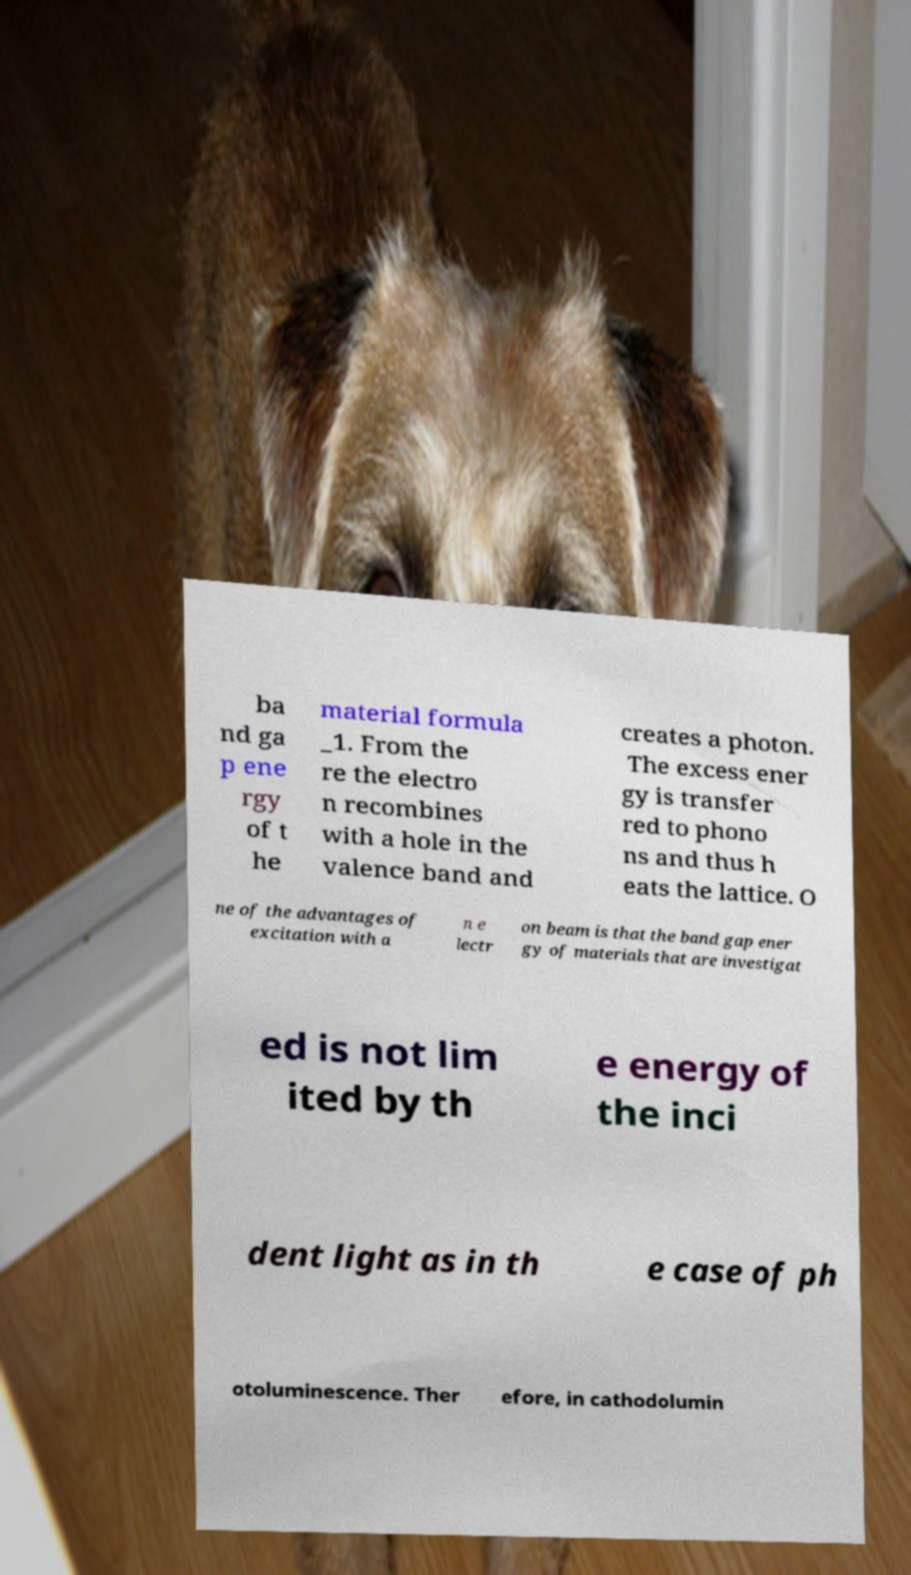Could you extract and type out the text from this image? ba nd ga p ene rgy of t he material formula _1. From the re the electro n recombines with a hole in the valence band and creates a photon. The excess ener gy is transfer red to phono ns and thus h eats the lattice. O ne of the advantages of excitation with a n e lectr on beam is that the band gap ener gy of materials that are investigat ed is not lim ited by th e energy of the inci dent light as in th e case of ph otoluminescence. Ther efore, in cathodolumin 